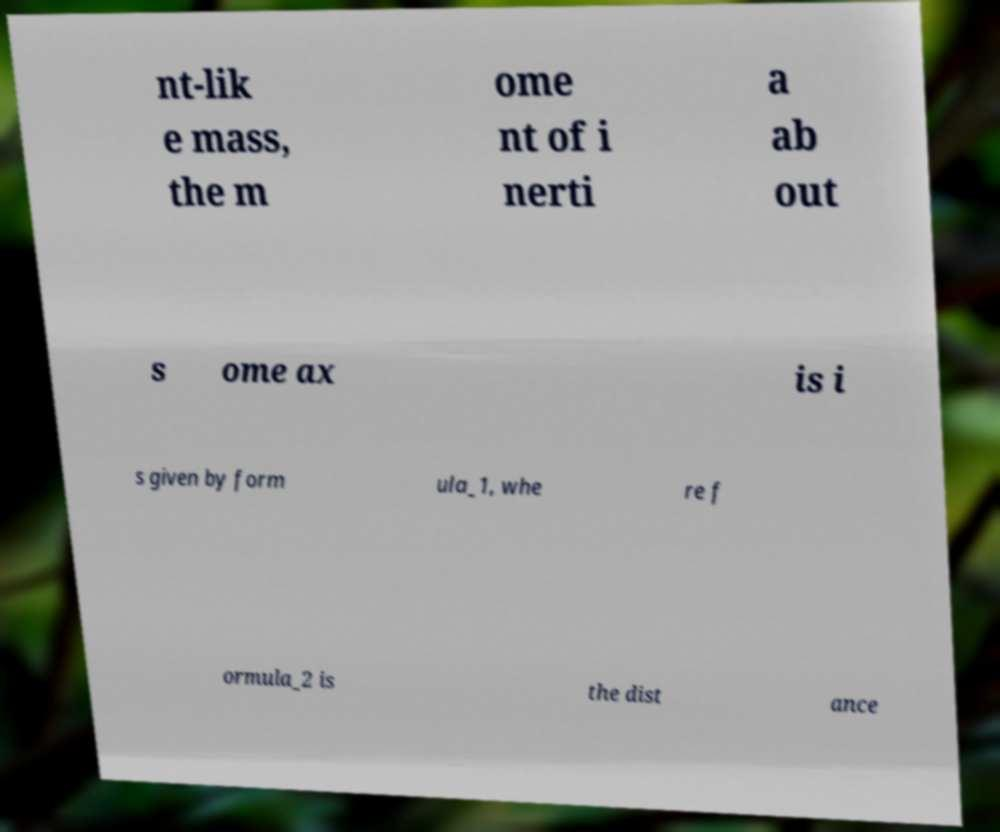For documentation purposes, I need the text within this image transcribed. Could you provide that? nt-lik e mass, the m ome nt of i nerti a ab out s ome ax is i s given by form ula_1, whe re f ormula_2 is the dist ance 